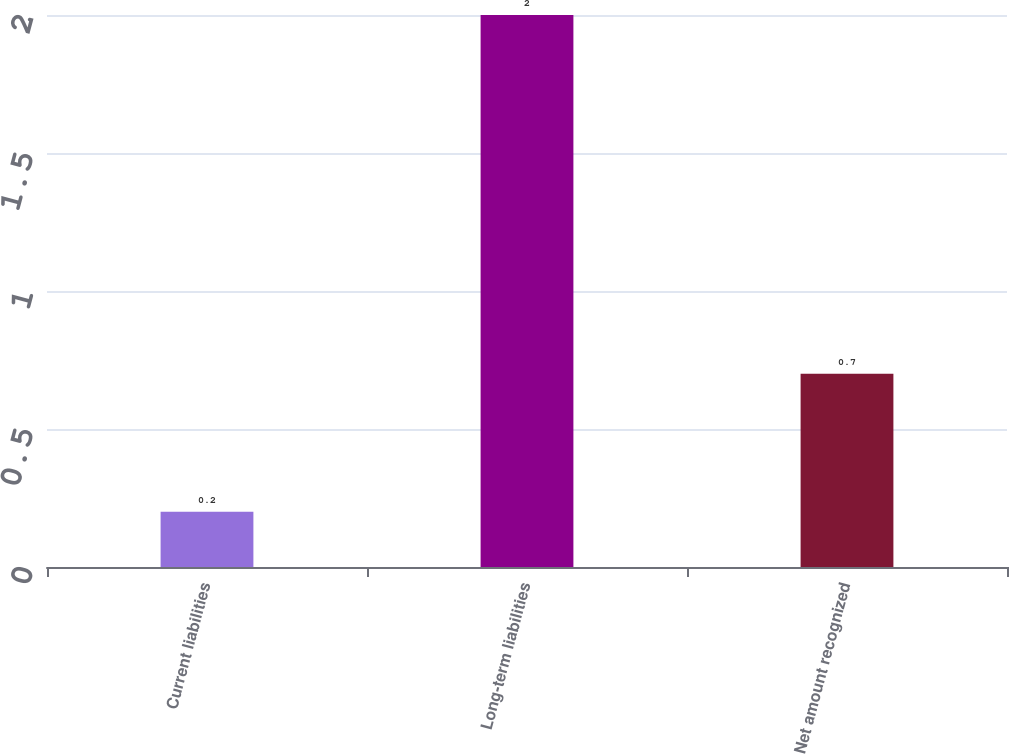Convert chart to OTSL. <chart><loc_0><loc_0><loc_500><loc_500><bar_chart><fcel>Current liabilities<fcel>Long-term liabilities<fcel>Net amount recognized<nl><fcel>0.2<fcel>2<fcel>0.7<nl></chart> 